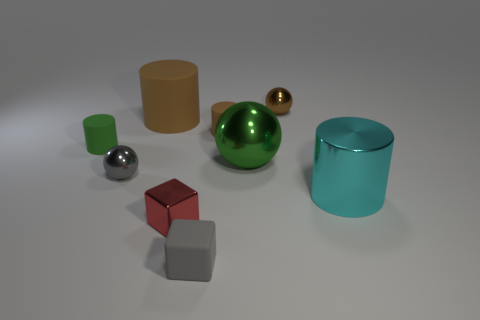Does the big cylinder in front of the small brown cylinder have the same material as the gray cube?
Provide a short and direct response. No. What is the color of the matte block that is the same size as the metal cube?
Offer a terse response. Gray. Are there any gray things that have the same shape as the green shiny thing?
Offer a very short reply. Yes. What is the color of the sphere that is behind the green thing that is on the right side of the gray object that is behind the tiny red cube?
Give a very brief answer. Brown. What number of metallic objects are either cyan cylinders or tiny red cubes?
Ensure brevity in your answer.  2. Is the number of big spheres behind the small brown cylinder greater than the number of green matte objects that are to the right of the green shiny thing?
Offer a very short reply. No. How many other things are the same size as the brown ball?
Ensure brevity in your answer.  5. There is a metal thing on the right side of the shiny sphere that is behind the tiny green rubber cylinder; how big is it?
Make the answer very short. Large. How many large things are either green things or matte balls?
Keep it short and to the point. 1. There is a brown matte object that is on the right side of the tiny red metallic cube that is in front of the small cylinder that is on the right side of the small green thing; what size is it?
Provide a short and direct response. Small. 